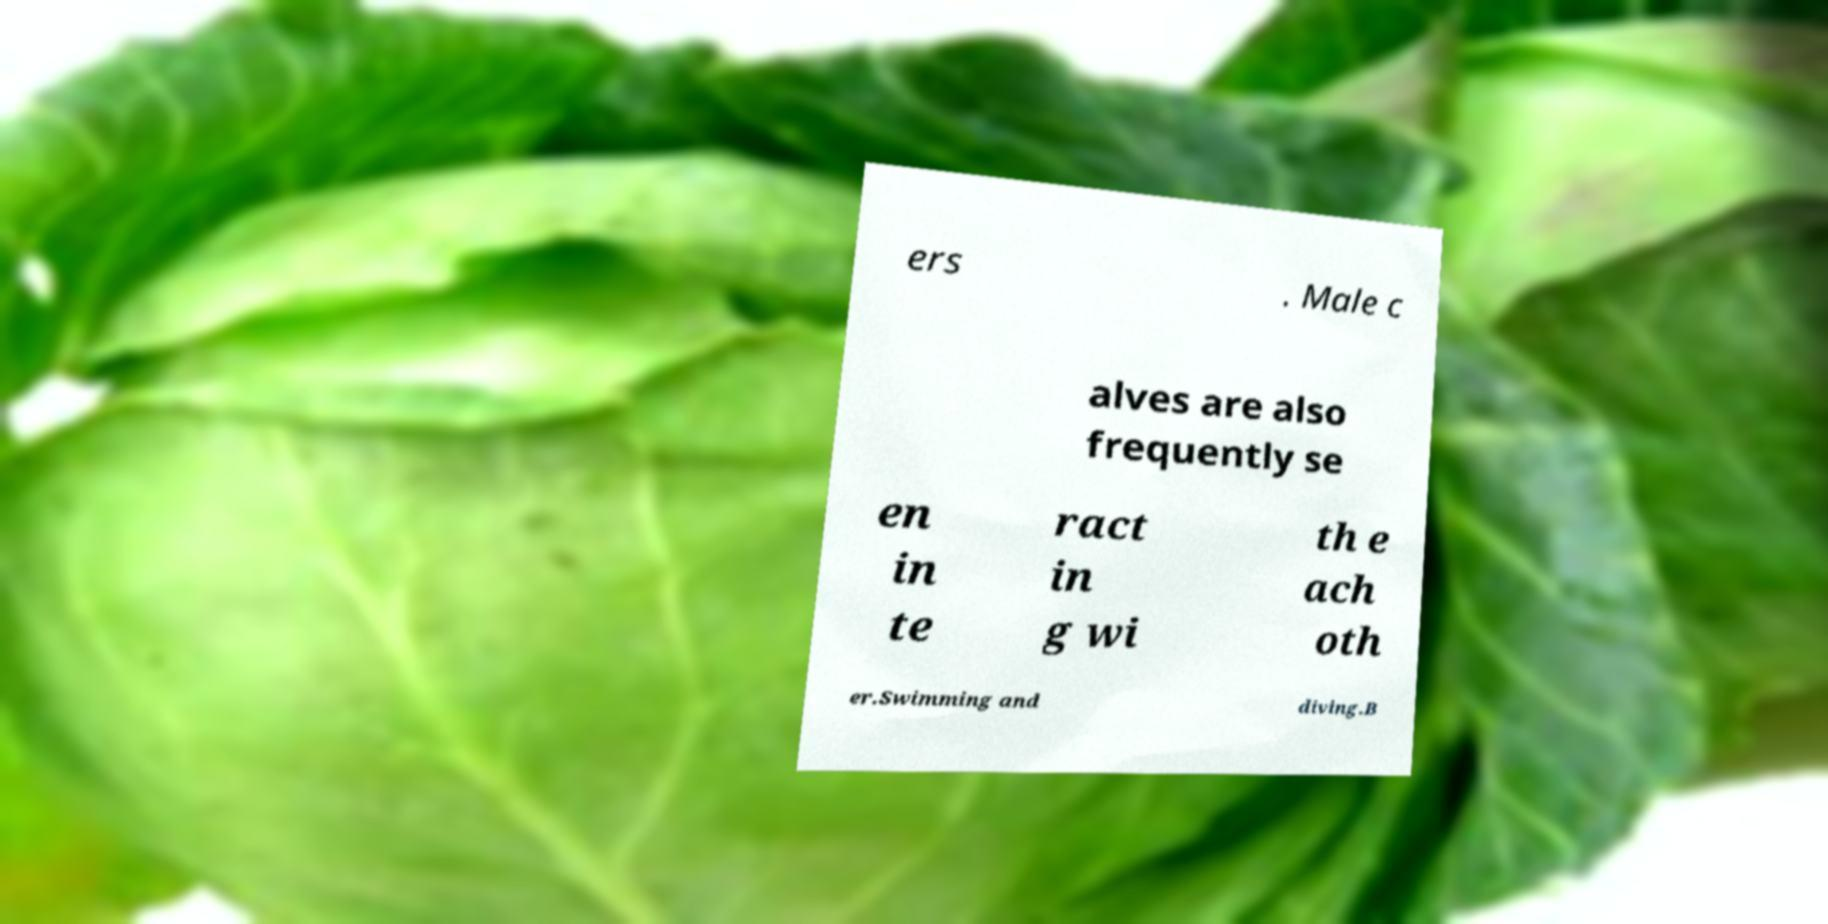Please identify and transcribe the text found in this image. ers . Male c alves are also frequently se en in te ract in g wi th e ach oth er.Swimming and diving.B 